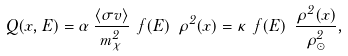Convert formula to latex. <formula><loc_0><loc_0><loc_500><loc_500>Q ( x , E ) = \alpha \, \frac { \langle \sigma v \rangle } { m ^ { 2 } _ { \chi } } \ f ( E ) \ \rho ^ { 2 } ( x ) = \kappa \ f ( E ) \ \frac { \rho ^ { 2 } ( x ) } { \rho _ { \odot } ^ { 2 } } ,</formula> 